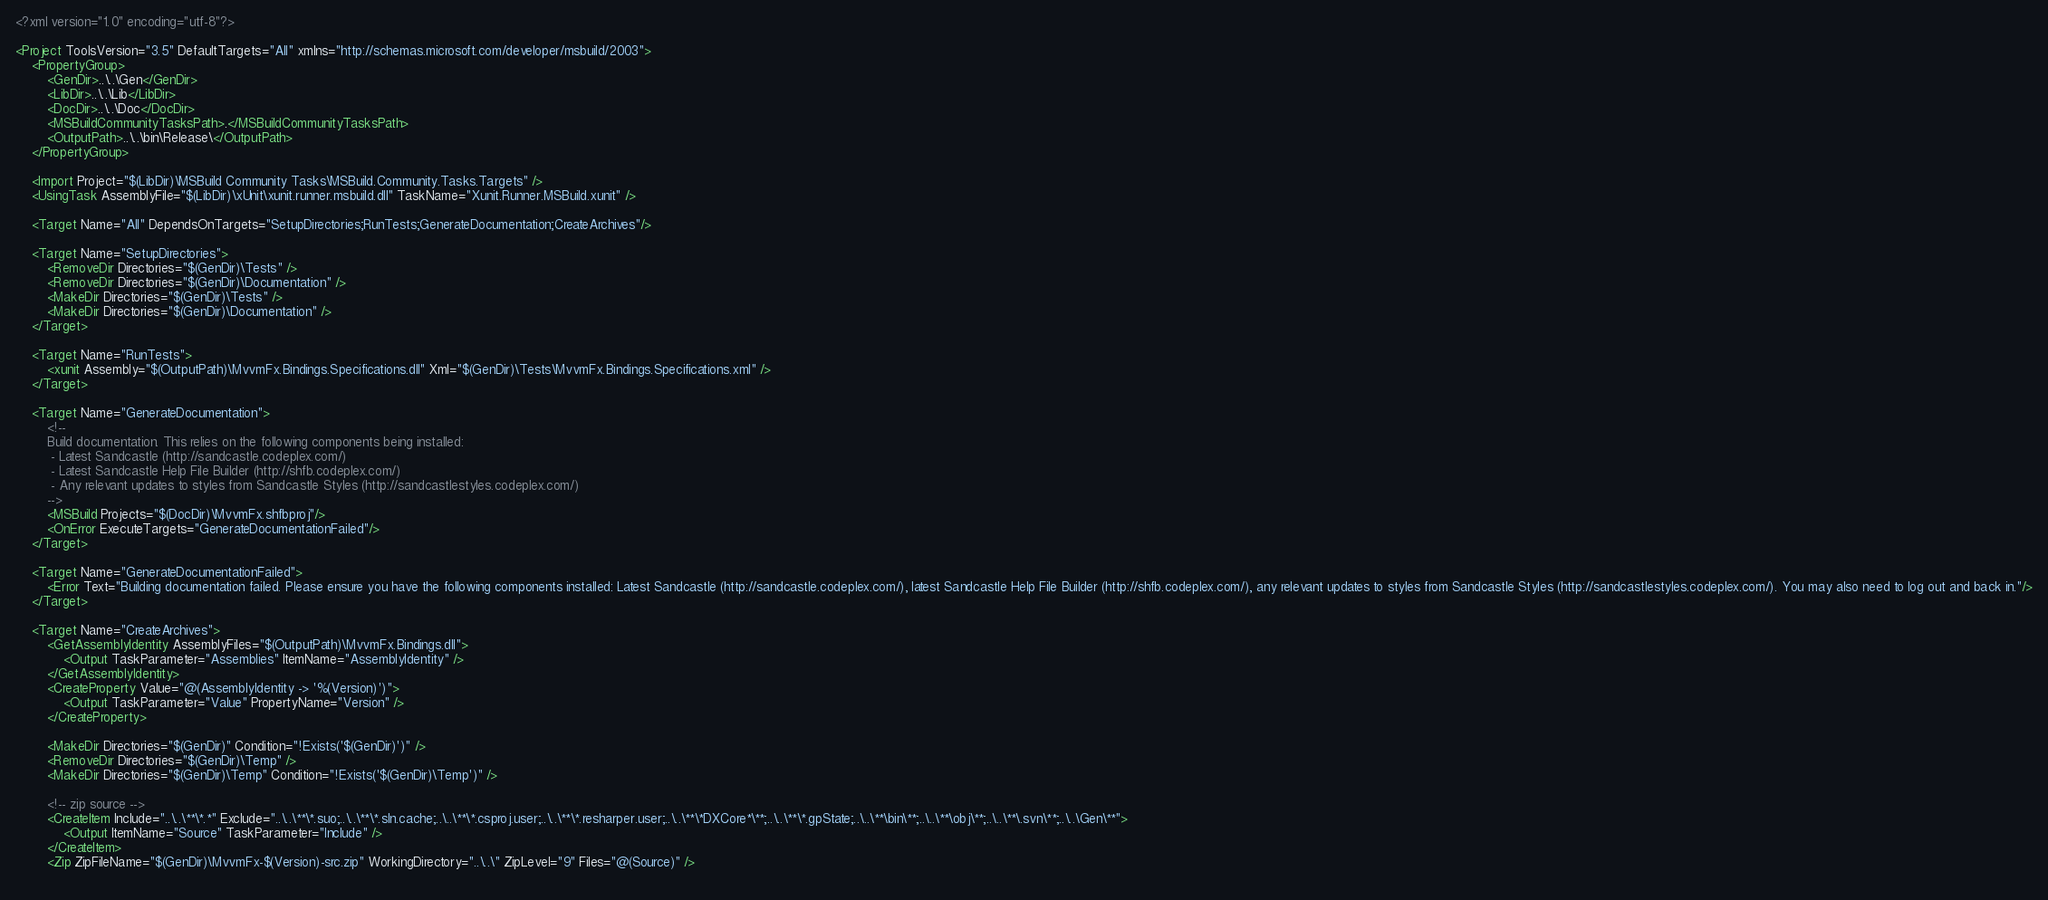Convert code to text. <code><loc_0><loc_0><loc_500><loc_500><_XML_><?xml version="1.0" encoding="utf-8"?>

<Project ToolsVersion="3.5" DefaultTargets="All" xmlns="http://schemas.microsoft.com/developer/msbuild/2003">
	<PropertyGroup>
		<GenDir>..\..\Gen</GenDir>
		<LibDir>..\..\Lib</LibDir>
		<DocDir>..\..\Doc</DocDir>
		<MSBuildCommunityTasksPath>.</MSBuildCommunityTasksPath>
		<OutputPath>..\..\bin\Release\</OutputPath>
	</PropertyGroup>

	<Import Project="$(LibDir)\MSBuild Community Tasks\MSBuild.Community.Tasks.Targets" />
	<UsingTask AssemblyFile="$(LibDir)\xUnit\xunit.runner.msbuild.dll" TaskName="Xunit.Runner.MSBuild.xunit" />

	<Target Name="All" DependsOnTargets="SetupDirectories;RunTests;GenerateDocumentation;CreateArchives"/>

	<Target Name="SetupDirectories">
		<RemoveDir Directories="$(GenDir)\Tests" />
		<RemoveDir Directories="$(GenDir)\Documentation" />
		<MakeDir Directories="$(GenDir)\Tests" />
		<MakeDir Directories="$(GenDir)\Documentation" />
	</Target>

	<Target Name="RunTests">
		<xunit Assembly="$(OutputPath)\MvvmFx.Bindings.Specifications.dll" Xml="$(GenDir)\Tests\MvvmFx.Bindings.Specifications.xml" />
	</Target>

	<Target Name="GenerateDocumentation">
		<!--
		Build documentation. This relies on the following components being installed:
		 - Latest Sandcastle (http://sandcastle.codeplex.com/)
		 - Latest Sandcastle Help File Builder (http://shfb.codeplex.com/)
		 - Any relevant updates to styles from Sandcastle Styles (http://sandcastlestyles.codeplex.com/)
		-->
		<MSBuild Projects="$(DocDir)\MvvmFx.shfbproj"/>
		<OnError ExecuteTargets="GenerateDocumentationFailed"/>
	</Target>

	<Target Name="GenerateDocumentationFailed">
		<Error Text="Building documentation failed. Please ensure you have the following components installed: Latest Sandcastle (http://sandcastle.codeplex.com/), latest Sandcastle Help File Builder (http://shfb.codeplex.com/), any relevant updates to styles from Sandcastle Styles (http://sandcastlestyles.codeplex.com/). You may also need to log out and back in."/>
	</Target>

	<Target Name="CreateArchives">
		<GetAssemblyIdentity AssemblyFiles="$(OutputPath)\MvvmFx.Bindings.dll">
			<Output TaskParameter="Assemblies" ItemName="AssemblyIdentity" />
		</GetAssemblyIdentity>
		<CreateProperty Value="@(AssemblyIdentity -> '%(Version)')">
			<Output TaskParameter="Value" PropertyName="Version" />
		</CreateProperty>
		
		<MakeDir Directories="$(GenDir)" Condition="!Exists('$(GenDir)')" />
		<RemoveDir Directories="$(GenDir)\Temp" />
		<MakeDir Directories="$(GenDir)\Temp" Condition="!Exists('$(GenDir)\Temp')" />
		
		<!-- zip source -->
		<CreateItem Include="..\..\**\*.*" Exclude="..\..\**\*.suo;..\..\**\*.sln.cache;..\..\**\*.csproj.user;..\..\**\*.resharper.user;..\..\**\*DXCore*\**;..\..\**\*.gpState;..\..\**\bin\**;..\..\**\obj\**;..\..\**\.svn\**;..\..\Gen\**">
			<Output ItemName="Source" TaskParameter="Include" />
		</CreateItem>
		<Zip ZipFileName="$(GenDir)\MvvmFx-$(Version)-src.zip" WorkingDirectory="..\..\" ZipLevel="9" Files="@(Source)" />
		</code> 